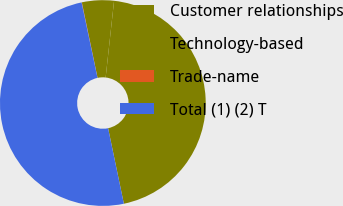Convert chart to OTSL. <chart><loc_0><loc_0><loc_500><loc_500><pie_chart><fcel>Customer relationships<fcel>Technology-based<fcel>Trade-name<fcel>Total (1) (2) T<nl><fcel>44.98%<fcel>5.02%<fcel>0.04%<fcel>49.96%<nl></chart> 